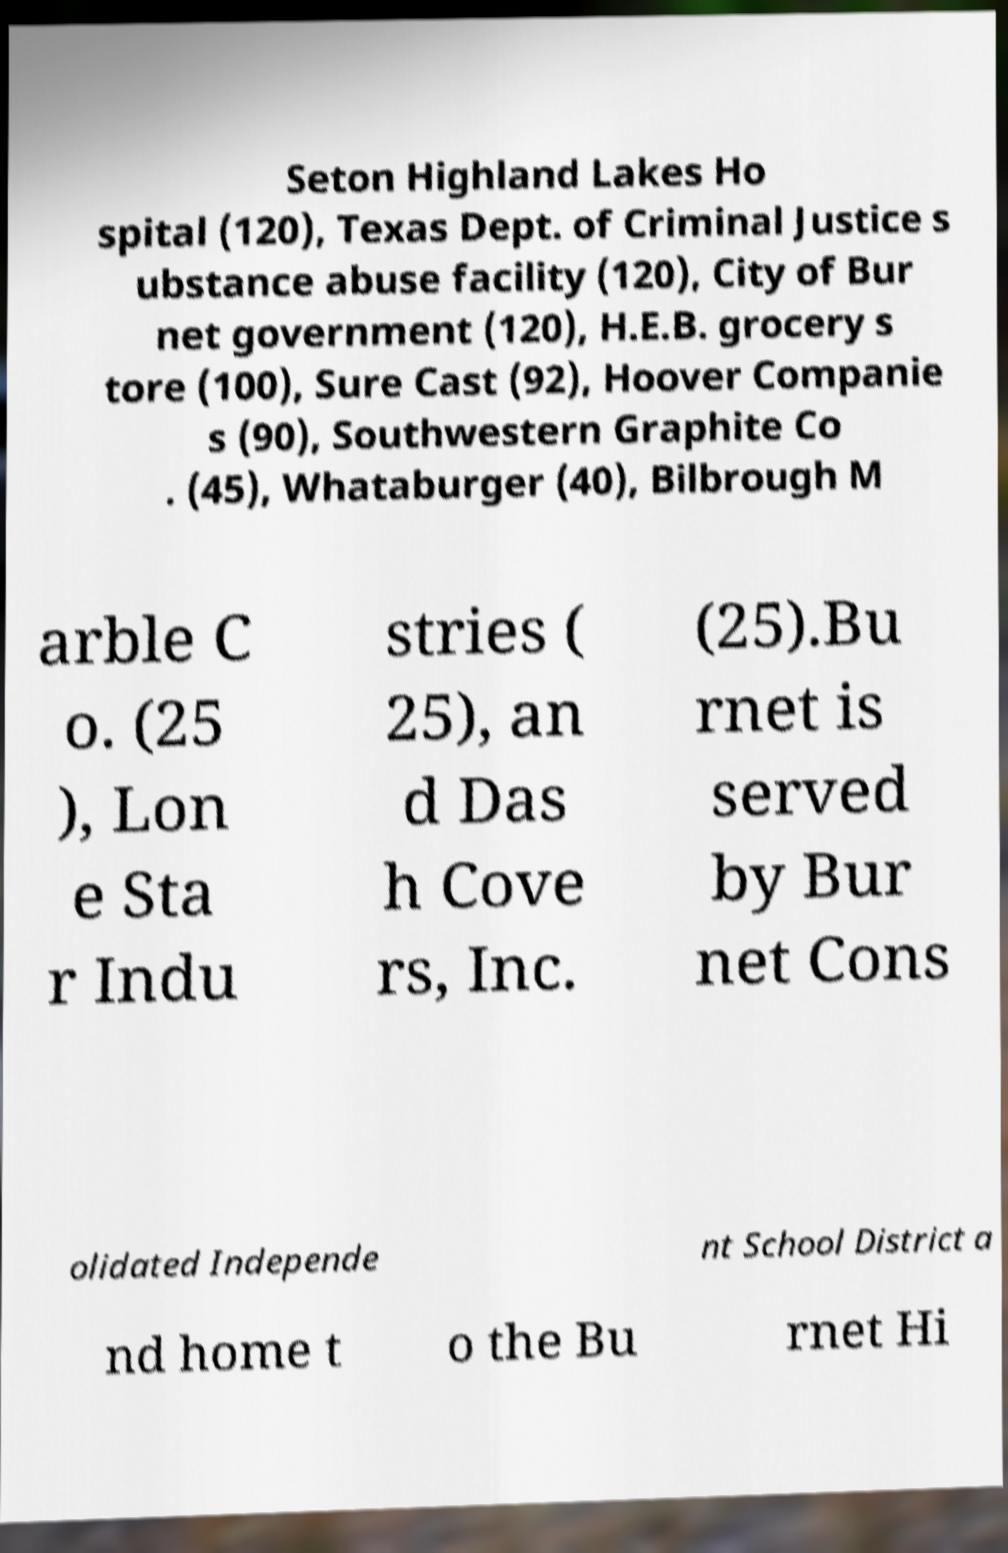What messages or text are displayed in this image? I need them in a readable, typed format. Seton Highland Lakes Ho spital (120), Texas Dept. of Criminal Justice s ubstance abuse facility (120), City of Bur net government (120), H.E.B. grocery s tore (100), Sure Cast (92), Hoover Companie s (90), Southwestern Graphite Co . (45), Whataburger (40), Bilbrough M arble C o. (25 ), Lon e Sta r Indu stries ( 25), an d Das h Cove rs, Inc. (25).Bu rnet is served by Bur net Cons olidated Independe nt School District a nd home t o the Bu rnet Hi 